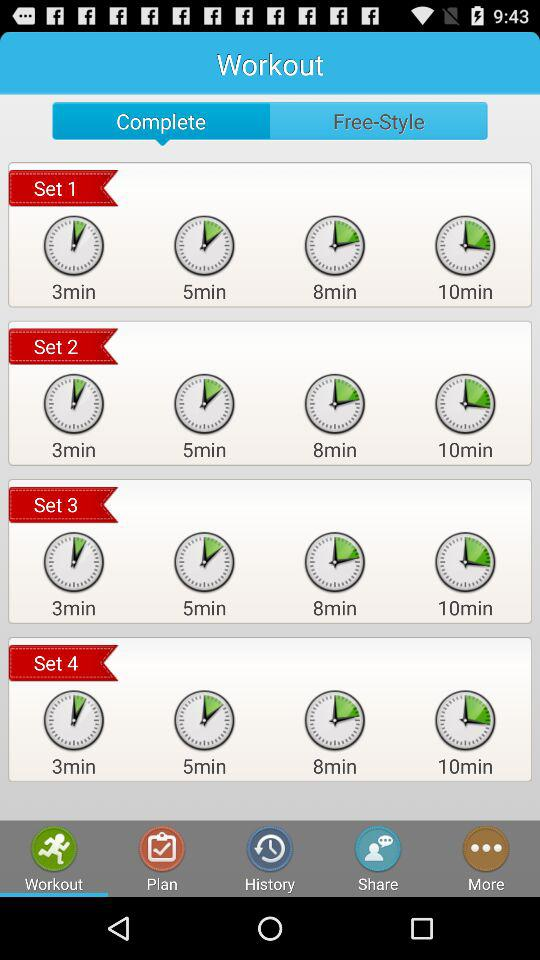Which option is selected? The selected options are "Complete" and "Workout". 